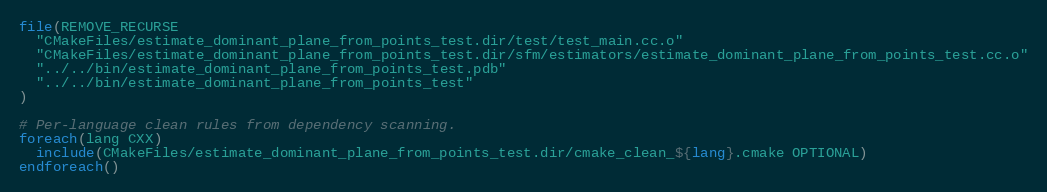<code> <loc_0><loc_0><loc_500><loc_500><_CMake_>file(REMOVE_RECURSE
  "CMakeFiles/estimate_dominant_plane_from_points_test.dir/test/test_main.cc.o"
  "CMakeFiles/estimate_dominant_plane_from_points_test.dir/sfm/estimators/estimate_dominant_plane_from_points_test.cc.o"
  "../../bin/estimate_dominant_plane_from_points_test.pdb"
  "../../bin/estimate_dominant_plane_from_points_test"
)

# Per-language clean rules from dependency scanning.
foreach(lang CXX)
  include(CMakeFiles/estimate_dominant_plane_from_points_test.dir/cmake_clean_${lang}.cmake OPTIONAL)
endforeach()
</code> 